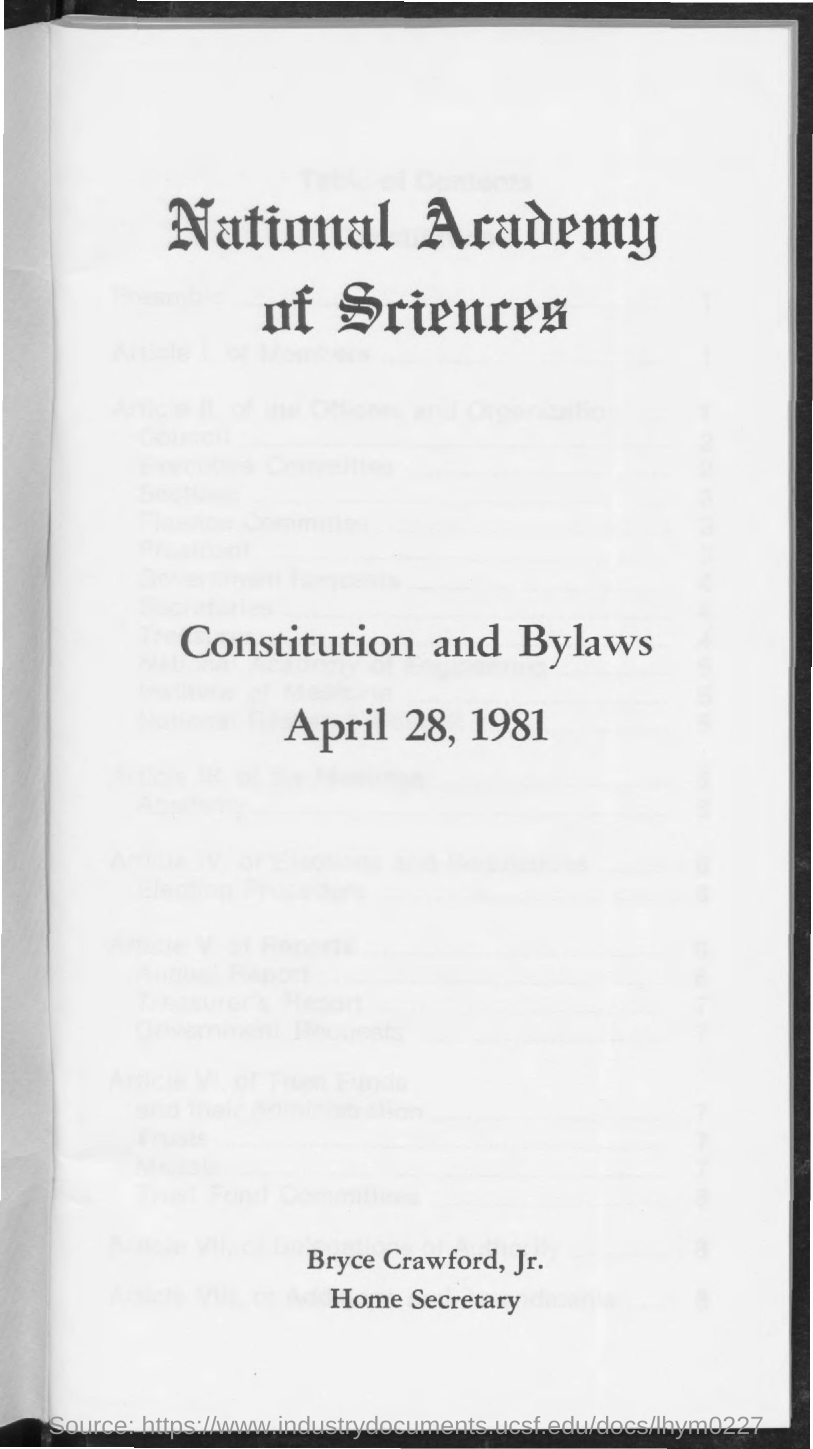Point out several critical features in this image. The date mentioned is April 28, 1981. Bryce Crawford, Jr. is the current Home Secretary. 